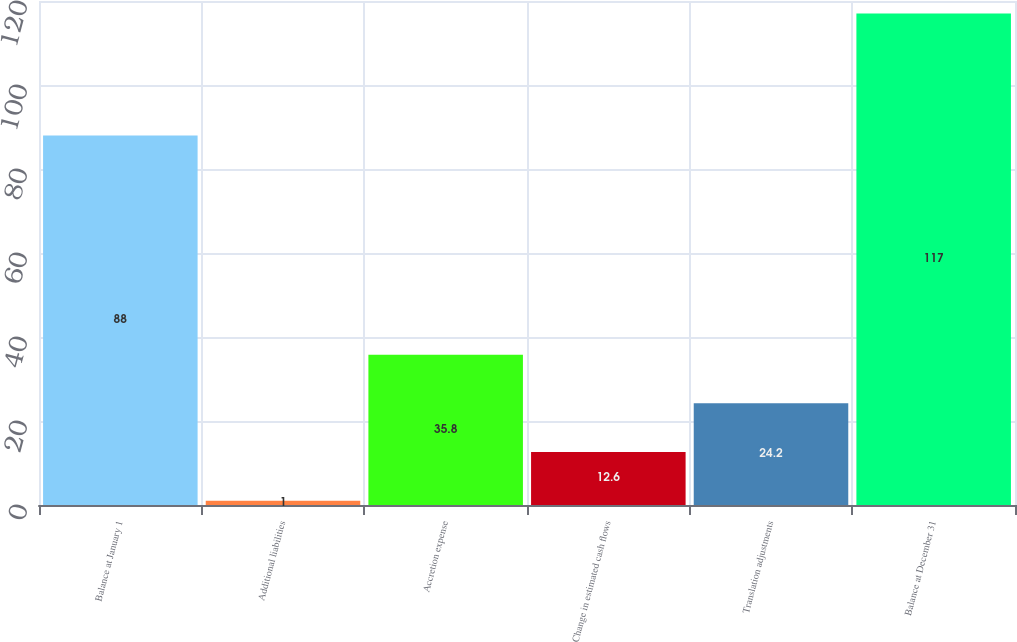<chart> <loc_0><loc_0><loc_500><loc_500><bar_chart><fcel>Balance at January 1<fcel>Additional liabilities<fcel>Accretion expense<fcel>Change in estimated cash flows<fcel>Translation adjustments<fcel>Balance at December 31<nl><fcel>88<fcel>1<fcel>35.8<fcel>12.6<fcel>24.2<fcel>117<nl></chart> 